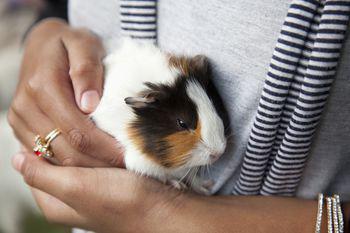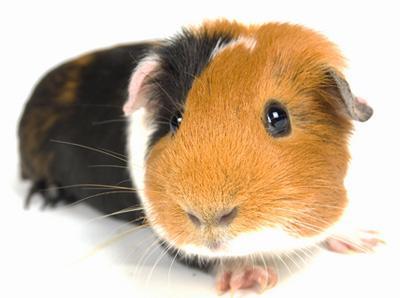The first image is the image on the left, the second image is the image on the right. Assess this claim about the two images: "there are exactly two animals in the image on the left". Correct or not? Answer yes or no. No. The first image is the image on the left, the second image is the image on the right. Considering the images on both sides, is "There are three hamsters." valid? Answer yes or no. No. 